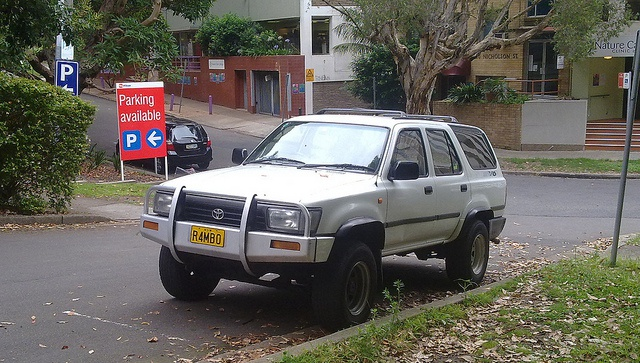Describe the objects in this image and their specific colors. I can see truck in black, white, gray, and darkgray tones, car in black, white, gray, and darkgray tones, and car in black, gray, and darkgray tones in this image. 